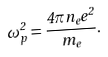<formula> <loc_0><loc_0><loc_500><loc_500>\omega _ { p } ^ { 2 } = \frac { 4 \pi n _ { e } e ^ { 2 } } { m _ { e } } .</formula> 